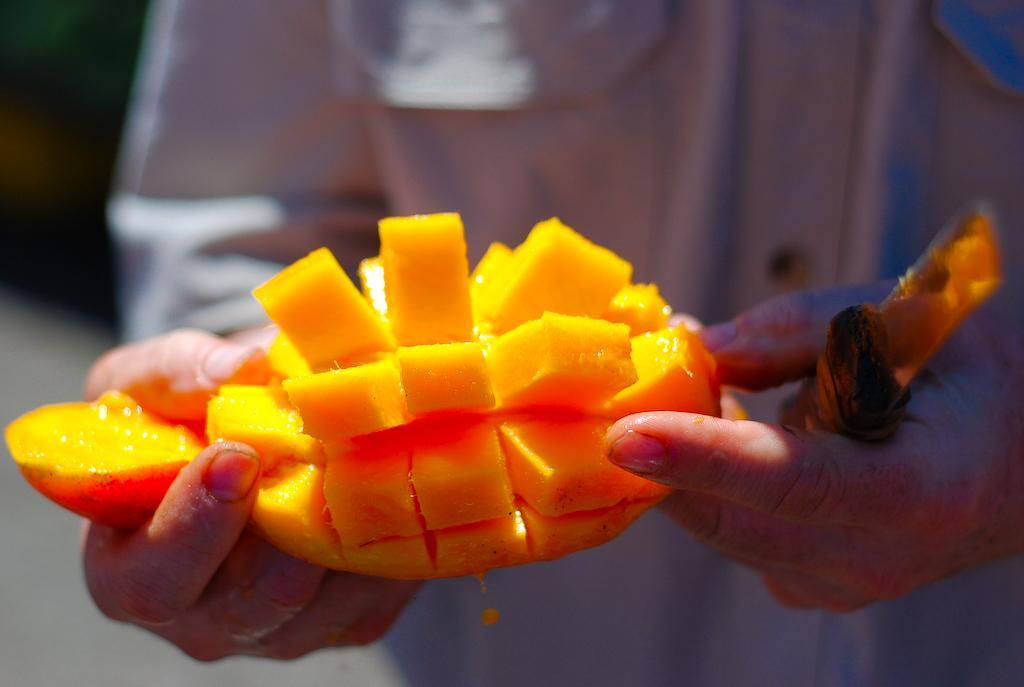In one or two sentences, can you explain what this image depicts? In this picture there is a person standing and holding the knife and sliced mangoes. 